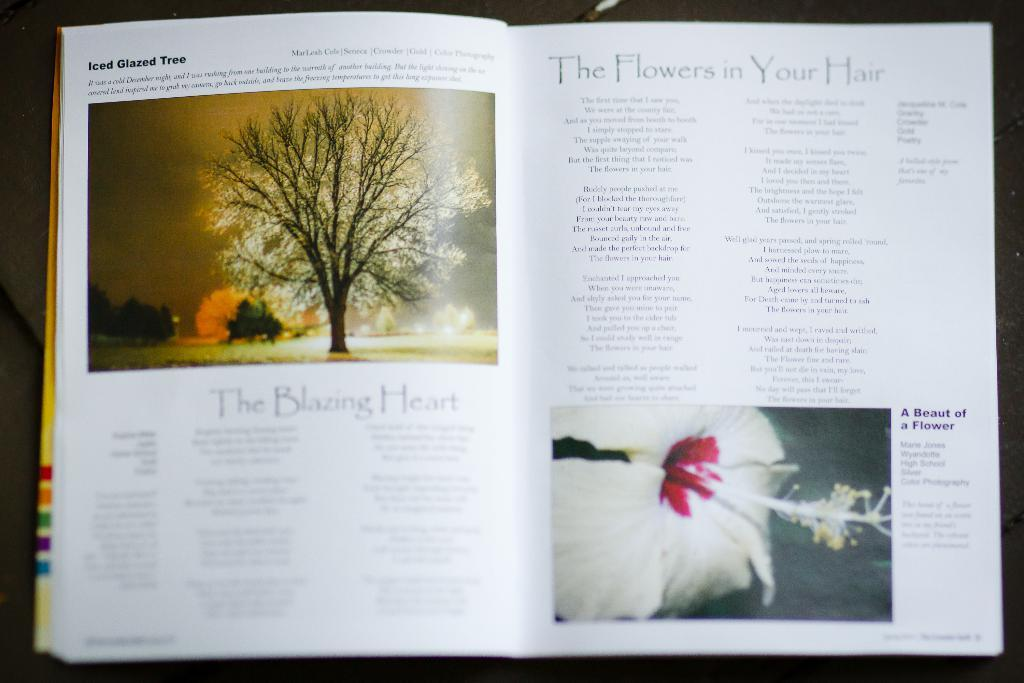What is the main object in the image? There is a book in the image. How many pages does the book have? The book has a few pages. What can be found on the pages of the book? There is text and images on the pages of the book. What type of meat is being prepared on the baseball field in the image? There is no baseball field or meat present in the image; it features a book with text and images on its pages. 